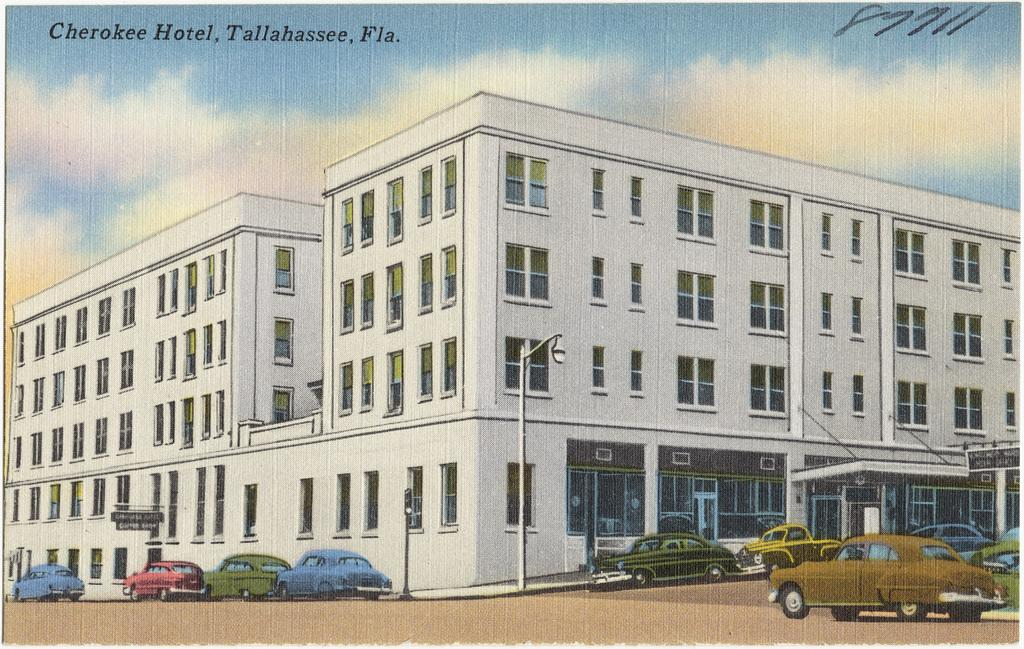What type of image is being described? The image is graphical in nature. What can be seen in the image besides the graphical elements? There are vehicles, poles, a building, clouds, and the sky visible in the image. Can you describe the vehicles in the image? The provided facts do not give specific details about the vehicles, so we cannot describe them further. What is the condition of the sky in the image? The sky is visible at the top of the image, and there are clouds present. Is there any text or logo in the image? Yes, there is a watermark in the image. What type of ray is visible in the image? There is no ray present in the image; it is a graphical representation of vehicles, poles, a building, clouds, and the sky. Can you describe the battle taking place in the image? There is no battle depicted in the image; it is a graphical representation of vehicles, poles, a building, clouds, and the sky. 